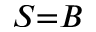<formula> <loc_0><loc_0><loc_500><loc_500>S { = } B</formula> 